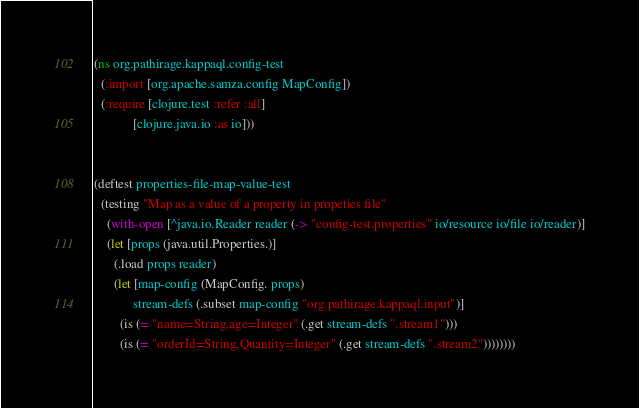Convert code to text. <code><loc_0><loc_0><loc_500><loc_500><_Clojure_>(ns org.pathirage.kappaql.config-test
  (:import [org.apache.samza.config MapConfig])
  (:require [clojure.test :refer :all]
            [clojure.java.io :as io]))


(deftest properties-file-map-value-test
  (testing "Map as a value of a property in propeties file"
    (with-open [^java.io.Reader reader (-> "config-test.properties" io/resource io/file io/reader)]
    (let [props (java.util.Properties.)]
      (.load props reader)
      (let [map-config (MapConfig. props)
            stream-defs (.subset map-config "org.pathirage.kappaql.input")]
        (is (= "name=String,age=Integer" (.get stream-defs ".stream1")))
        (is (= "orderId=String,Quantity=Integer" (.get stream-defs ".stream2"))))))))</code> 